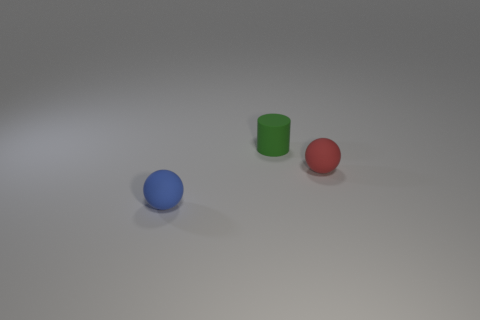Subtract all cylinders. How many objects are left? 2 Subtract 2 balls. How many balls are left? 0 Add 1 blue objects. How many objects exist? 4 Subtract all blue spheres. How many spheres are left? 1 Add 1 tiny rubber things. How many tiny rubber things are left? 4 Add 3 red spheres. How many red spheres exist? 4 Subtract 0 purple cylinders. How many objects are left? 3 Subtract all gray cylinders. Subtract all red balls. How many cylinders are left? 1 Subtract all yellow cylinders. How many blue balls are left? 1 Subtract all tiny rubber objects. Subtract all tiny red metal spheres. How many objects are left? 0 